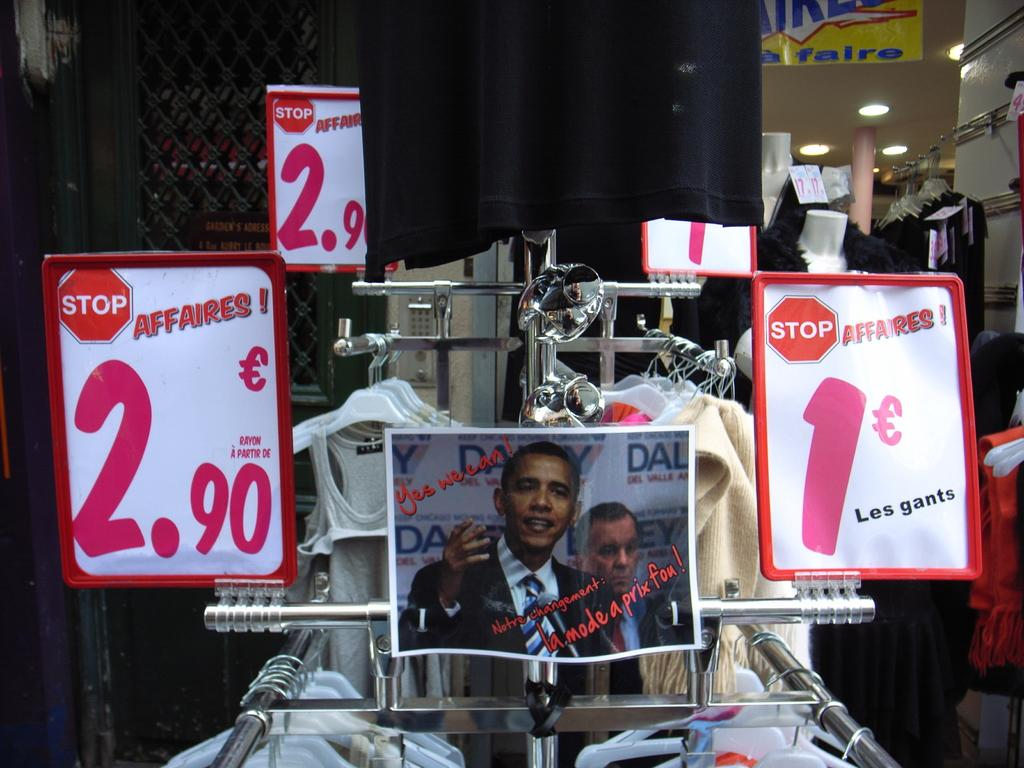What is the main object in the center of the image? There is a closet in the center of the image. What type of poster can be seen in the image? There is an Obama poster with red color text in the image. What kind of illumination is present in the image? The image contains lights. What items are related to clothing in the image? Clothes are present in the image. What objects provide information in the image? There are information boards in the image. What type of flowers are present in the image? There are no flowers present in the image. What kind of pleasure can be seen in the image? The image does not depict any pleasure or emotions; it focuses on the objects and their arrangement. 